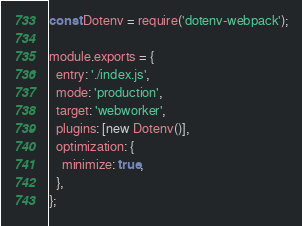Convert code to text. <code><loc_0><loc_0><loc_500><loc_500><_JavaScript_>const Dotenv = require('dotenv-webpack');

module.exports = {
  entry: './index.js',
  mode: 'production',
  target: 'webworker',
  plugins: [new Dotenv()],
  optimization: {
    minimize: true,
  },
};
</code> 